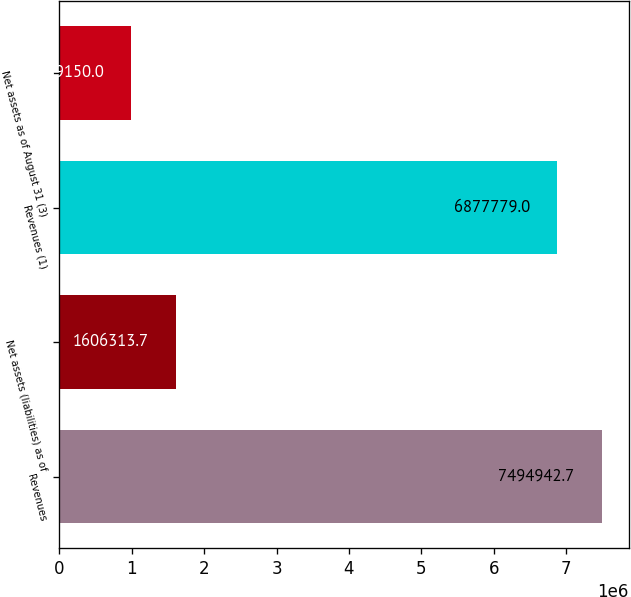Convert chart. <chart><loc_0><loc_0><loc_500><loc_500><bar_chart><fcel>Revenues<fcel>Net assets (liabilities) as of<fcel>Revenues (1)<fcel>Net assets as of August 31 (3)<nl><fcel>7.49494e+06<fcel>1.60631e+06<fcel>6.87778e+06<fcel>989150<nl></chart> 